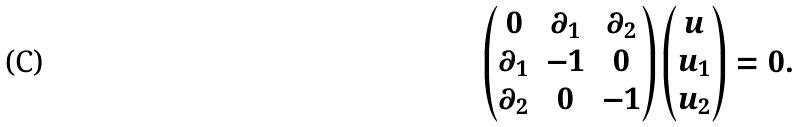Convert formula to latex. <formula><loc_0><loc_0><loc_500><loc_500>\begin{pmatrix} 0 & \partial _ { 1 } & \partial _ { 2 } \\ \partial _ { 1 } & - 1 & 0 \\ \partial _ { 2 } & 0 & - 1 \end{pmatrix} \begin{pmatrix} u \\ u _ { 1 } \\ u _ { 2 } \\ \end{pmatrix} = 0 .</formula> 